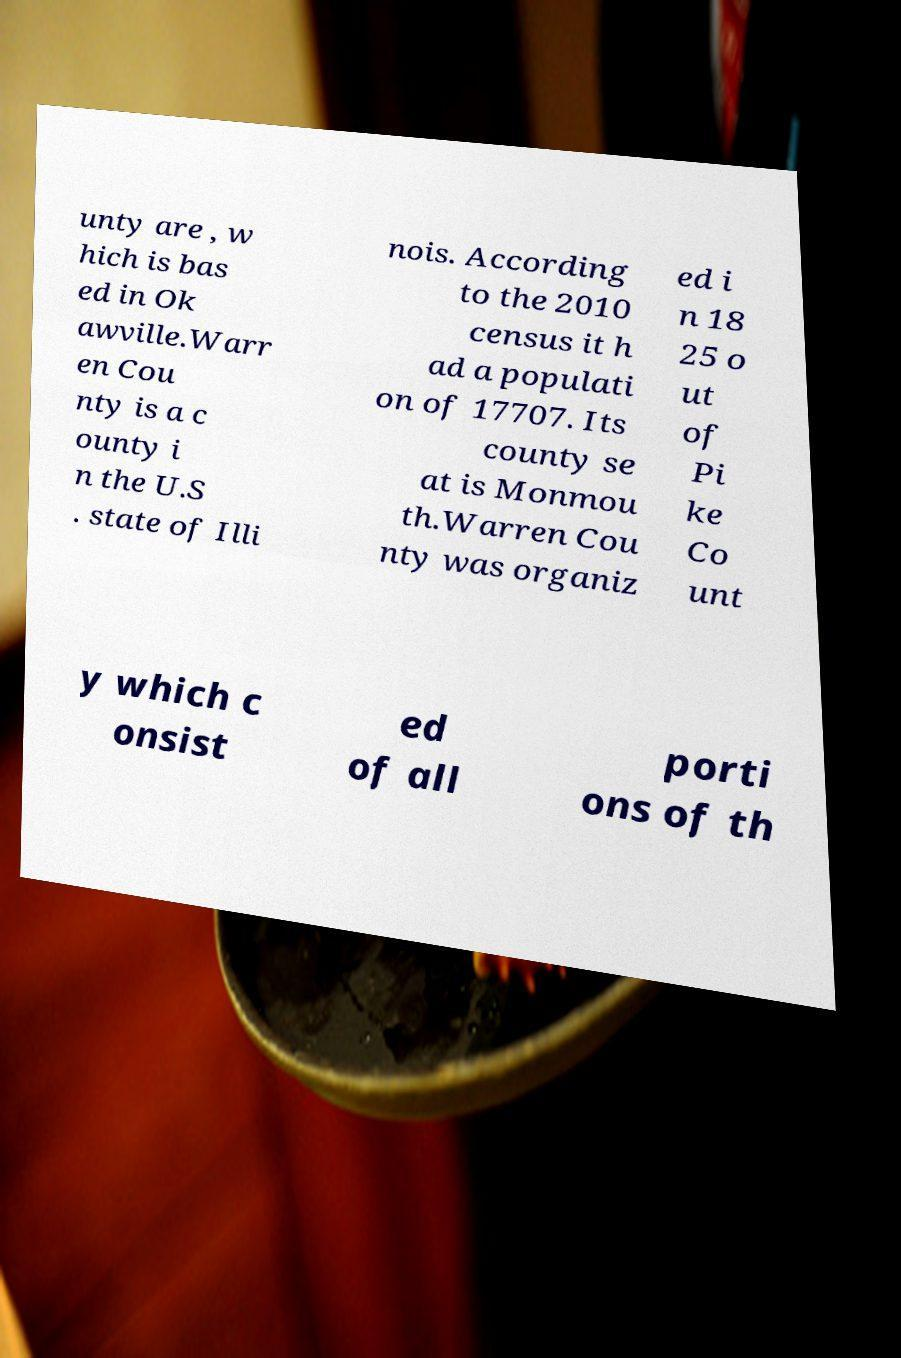What messages or text are displayed in this image? I need them in a readable, typed format. unty are , w hich is bas ed in Ok awville.Warr en Cou nty is a c ounty i n the U.S . state of Illi nois. According to the 2010 census it h ad a populati on of 17707. Its county se at is Monmou th.Warren Cou nty was organiz ed i n 18 25 o ut of Pi ke Co unt y which c onsist ed of all porti ons of th 